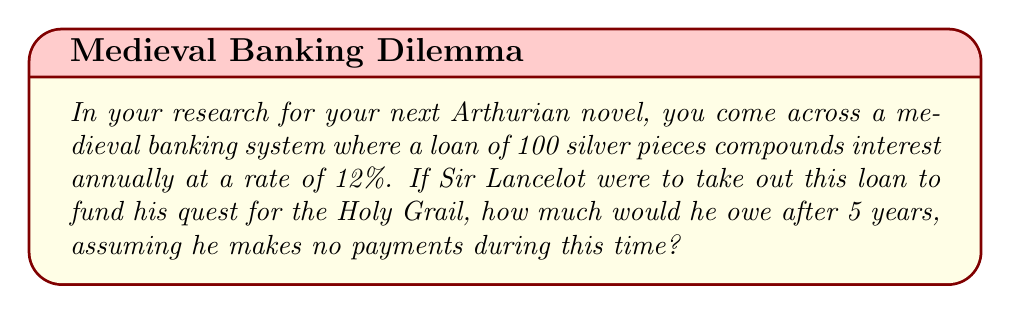Could you help me with this problem? To solve this problem, we need to use the compound interest formula:

$$A = P(1 + r)^n$$

Where:
$A$ = the final amount
$P$ = the principal (initial loan amount)
$r$ = the annual interest rate (in decimal form)
$n$ = the number of years

Given:
$P = 100$ silver pieces
$r = 12\% = 0.12$
$n = 5$ years

Let's substitute these values into the formula:

$$A = 100(1 + 0.12)^5$$

Now, let's solve step by step:

1) First, calculate $(1 + 0.12)$:
   $1 + 0.12 = 1.12$

2) Now, we need to calculate $1.12^5$:
   $1.12^5 = 1.7623$

3) Finally, multiply this by the principal:
   $100 \times 1.7623 = 176.23$

Therefore, after 5 years, Sir Lancelot would owe 176.23 silver pieces.
Answer: 176.23 silver pieces 